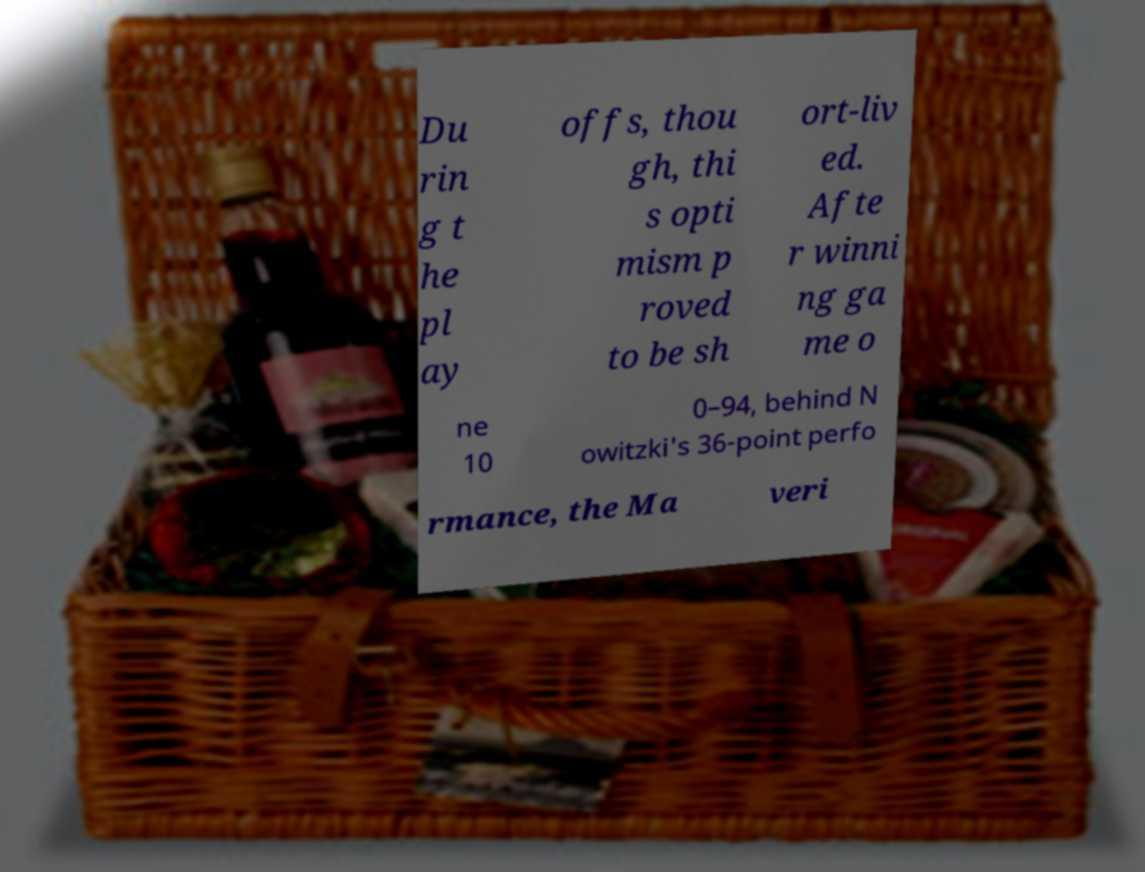What messages or text are displayed in this image? I need them in a readable, typed format. Du rin g t he pl ay offs, thou gh, thi s opti mism p roved to be sh ort-liv ed. Afte r winni ng ga me o ne 10 0–94, behind N owitzki's 36-point perfo rmance, the Ma veri 